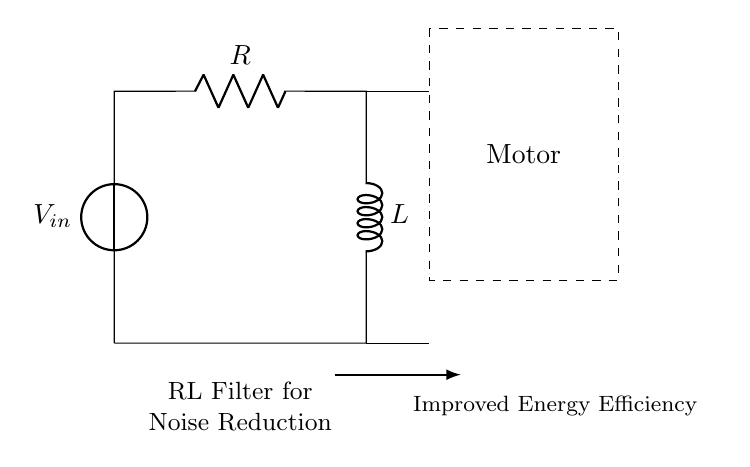what type of circuit is this? This circuit is an RL filter circuit, which consists of a resistor and an inductor connected in series. The components are explicitly shown: the resistor is labeled R and the inductor is labeled L.
Answer: RL filter circuit what is the purpose of the inductor in this circuit? The purpose of the inductor in an RL filter circuit is to oppose changes in current, thereby reducing electrical noise and smoothing the output. This function helps in filtering out high-frequency noise from the motor.
Answer: reduce electrical noise what is located within the dashed rectangle? The dashed rectangle contains the motor, which indicates that this RL filter circuit is used to connect and filter the motor's power supply to minimize noise.
Answer: Motor how does this circuit improve energy efficiency? This circuit improves energy efficiency by filtering out unwanted high-frequency noise, allowing the motor to operate more efficiently with less wasted energy associated with noise and interference.
Answer: filters noise what is the main function of the resistor in this RL circuit? The main function of the resistor in this RL circuit is to limit current flow and help set the overall gain of the circuit, thereby contributing to the noise reduction by establishing a voltage drop.
Answer: limit current flow what happens to the noise from the motor when using this filter? The noise from the motor is reduced because the RL circuit attenuates high-frequency signals while allowing lower-frequency signals, resulting in a cleaner output.
Answer: reduced what role does the voltage source play in the circuit? The voltage source provides the necessary electrical energy to power the motor and the RL filter circuit, which is essential for the circuit's operation.
Answer: provides energy 